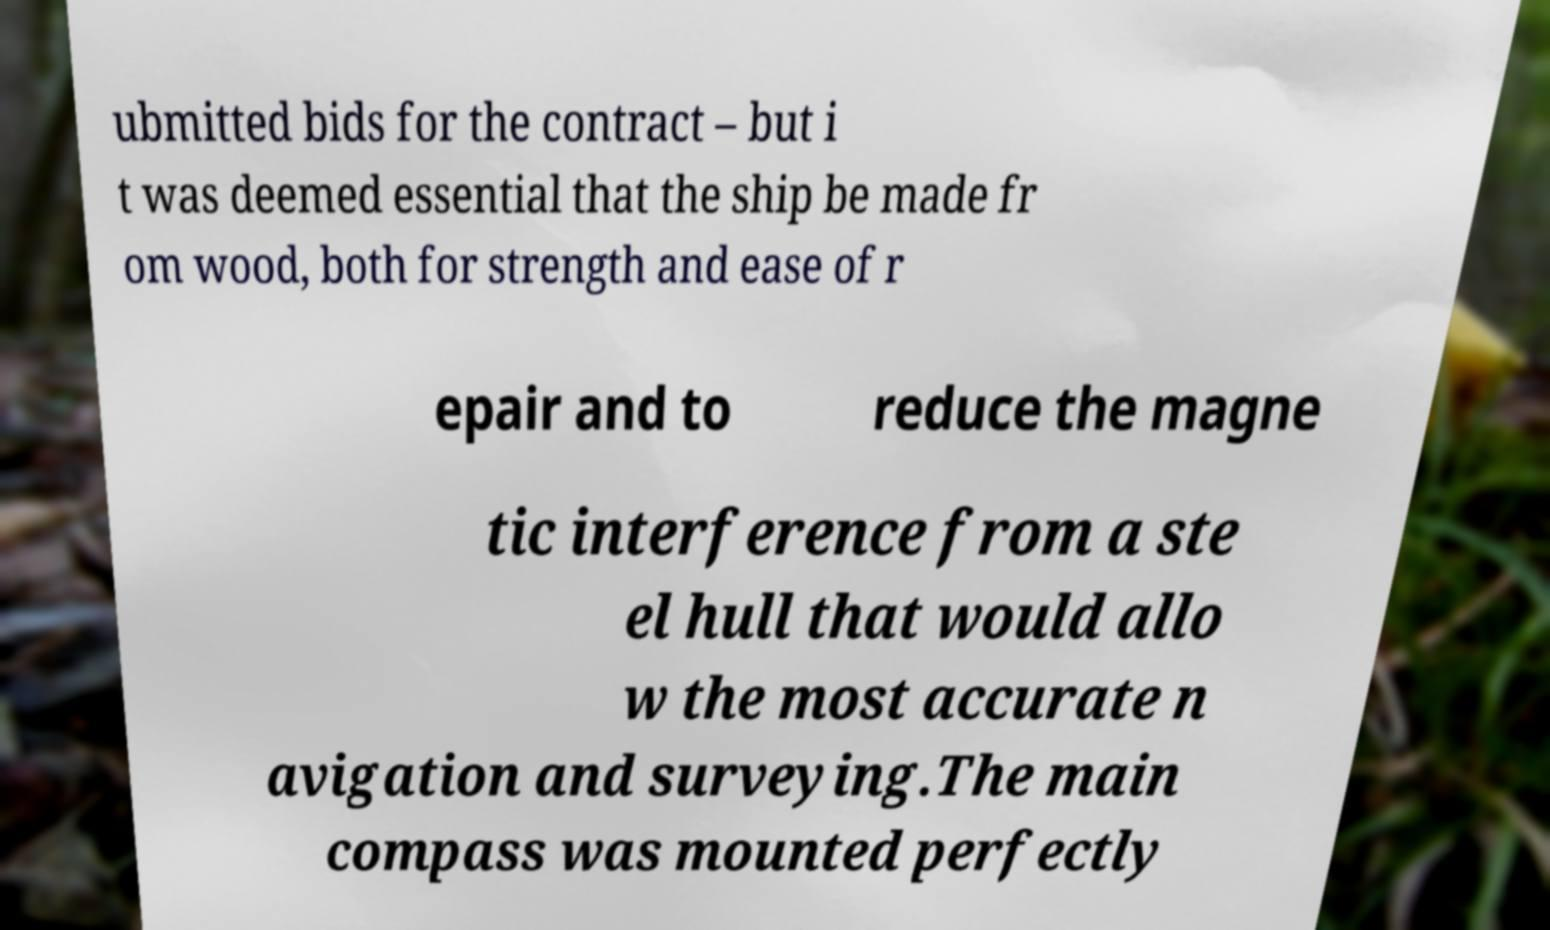There's text embedded in this image that I need extracted. Can you transcribe it verbatim? ubmitted bids for the contract – but i t was deemed essential that the ship be made fr om wood, both for strength and ease of r epair and to reduce the magne tic interference from a ste el hull that would allo w the most accurate n avigation and surveying.The main compass was mounted perfectly 